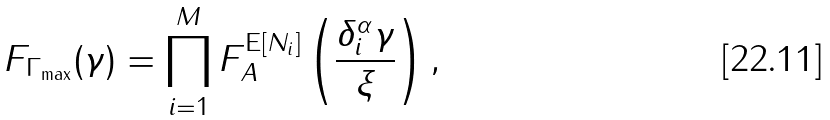<formula> <loc_0><loc_0><loc_500><loc_500>F _ { \Gamma _ { \max } } ( \gamma ) = \prod _ { i = 1 } ^ { M } F _ { A } ^ { \text {E} [ N _ { i } ] } \left ( \frac { \delta _ { i } ^ { \alpha } \gamma } { \xi } \right ) ,</formula> 